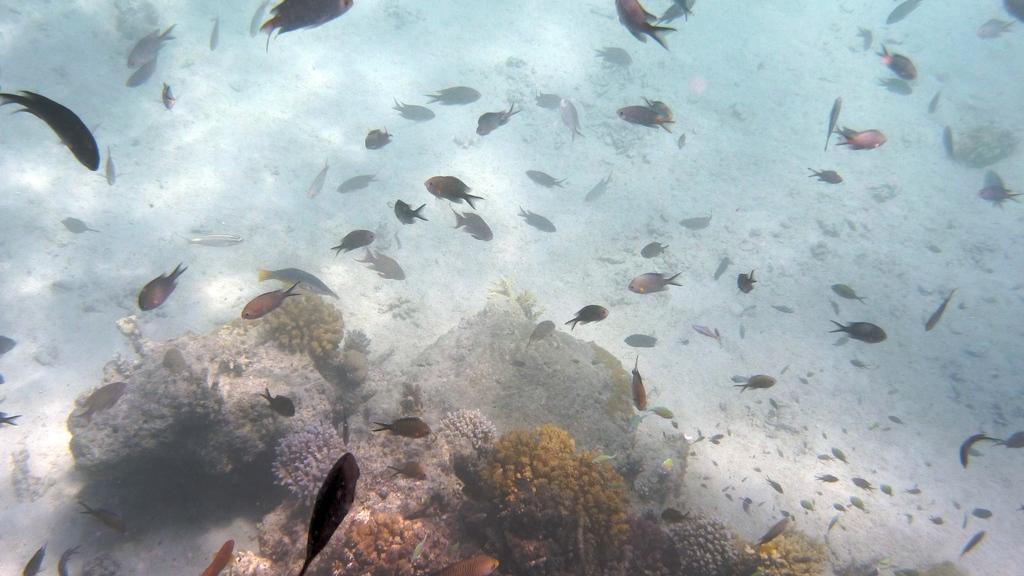Describe this image in one or two sentences. In the picture we can see inside the water, we can see some water plants, rocks and stones and different types of fishes. 